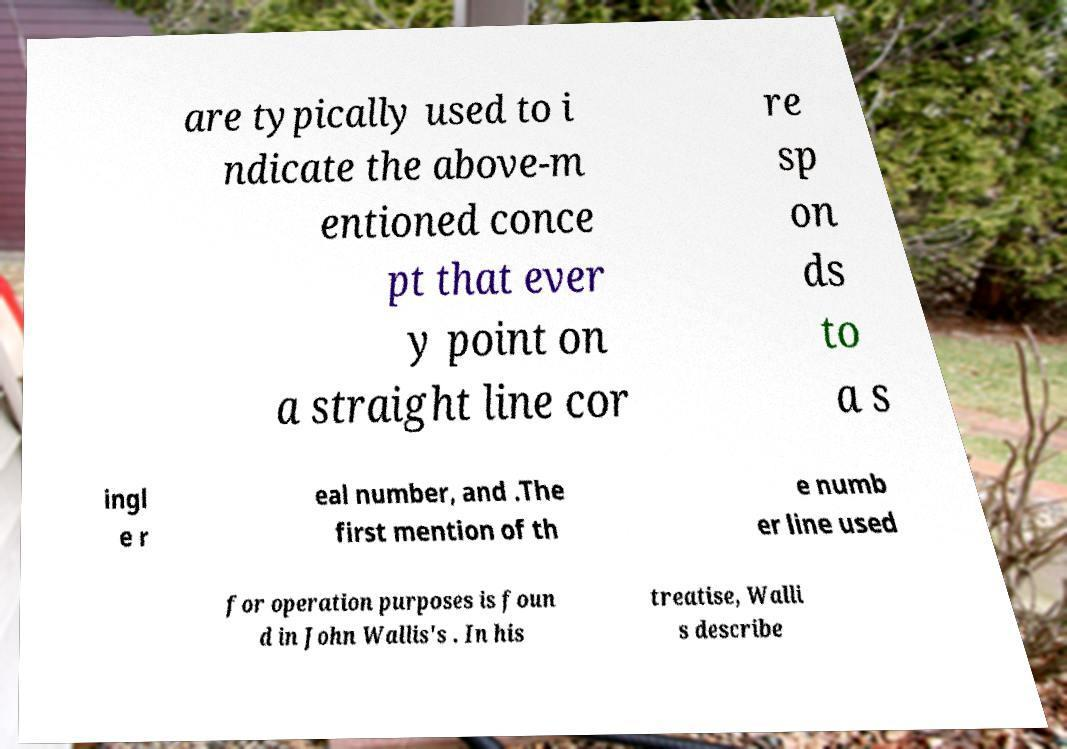Could you assist in decoding the text presented in this image and type it out clearly? are typically used to i ndicate the above-m entioned conce pt that ever y point on a straight line cor re sp on ds to a s ingl e r eal number, and .The first mention of th e numb er line used for operation purposes is foun d in John Wallis's . In his treatise, Walli s describe 